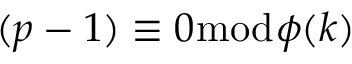Convert formula to latex. <formula><loc_0><loc_0><loc_500><loc_500>( p - 1 ) \equiv 0 { \bmod { \phi } } ( k )</formula> 